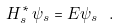Convert formula to latex. <formula><loc_0><loc_0><loc_500><loc_500>H ^ { * } _ { s } \, \psi _ { s } = E \psi _ { s } \ .</formula> 